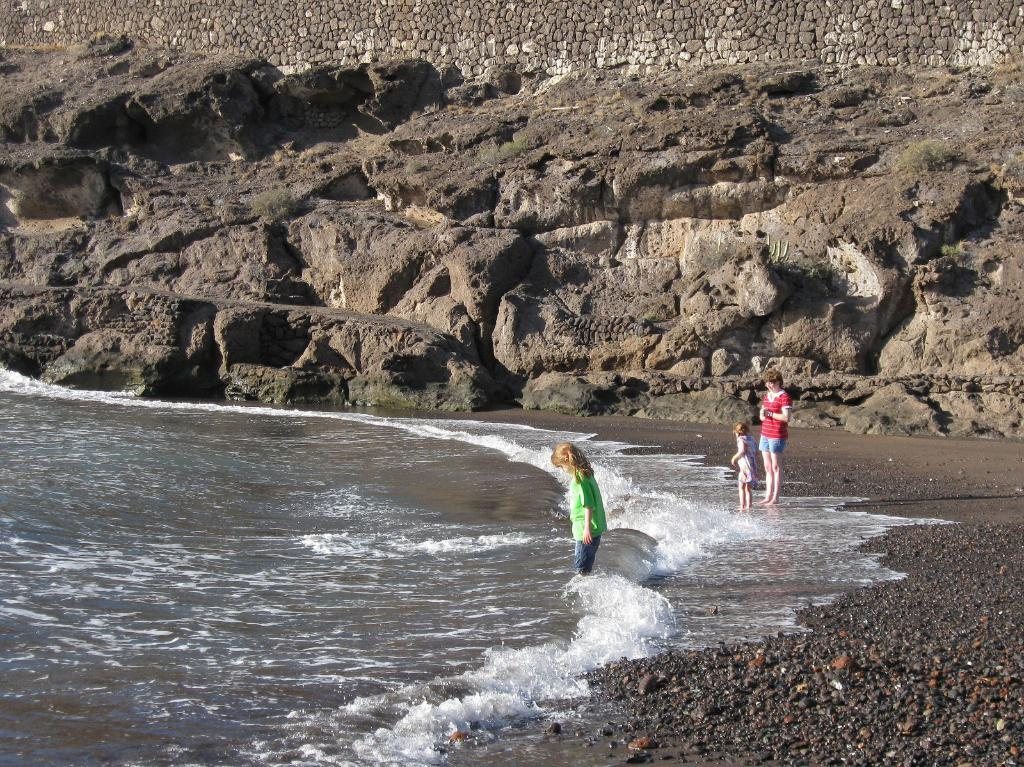What is the location of the people in the image? The people are standing at the sea shore. What is near the people in the image? There is a big rock near the people. What type of structure can be seen in the image? There is a stone wall in the image. What type of soap is being used by the people in the image? There is no soap present in the image; the people are standing at the sea shore. What type of oil can be seen in the image? There is no oil present in the image; the focus is on the people, the big rock, and the stone wall. 